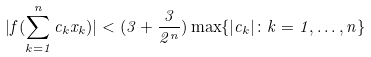Convert formula to latex. <formula><loc_0><loc_0><loc_500><loc_500>| f ( \sum _ { k = 1 } ^ { n } c _ { k } x _ { k } ) | < ( 3 + \frac { 3 } { 2 ^ { n } } ) \max \{ | c _ { k } | \colon k = 1 , \dots , n \}</formula> 